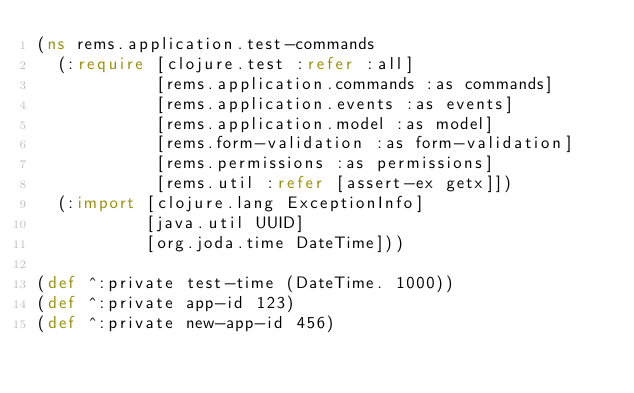<code> <loc_0><loc_0><loc_500><loc_500><_Clojure_>(ns rems.application.test-commands
  (:require [clojure.test :refer :all]
            [rems.application.commands :as commands]
            [rems.application.events :as events]
            [rems.application.model :as model]
            [rems.form-validation :as form-validation]
            [rems.permissions :as permissions]
            [rems.util :refer [assert-ex getx]])
  (:import [clojure.lang ExceptionInfo]
           [java.util UUID]
           [org.joda.time DateTime]))

(def ^:private test-time (DateTime. 1000))
(def ^:private app-id 123)
(def ^:private new-app-id 456)</code> 